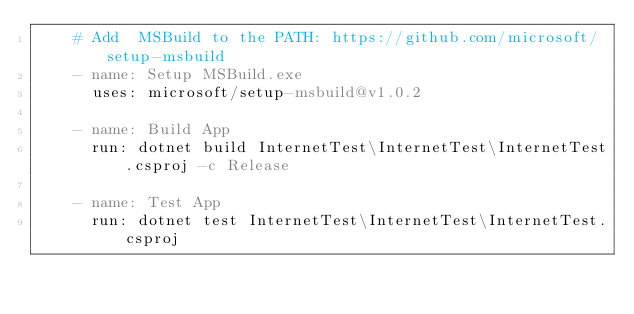Convert code to text. <code><loc_0><loc_0><loc_500><loc_500><_YAML_>    # Add  MSBuild to the PATH: https://github.com/microsoft/setup-msbuild
    - name: Setup MSBuild.exe
      uses: microsoft/setup-msbuild@v1.0.2
      
    - name: Build App
      run: dotnet build InternetTest\InternetTest\InternetTest.csproj -c Release
    
    - name: Test App
      run: dotnet test InternetTest\InternetTest\InternetTest.csproj
</code> 